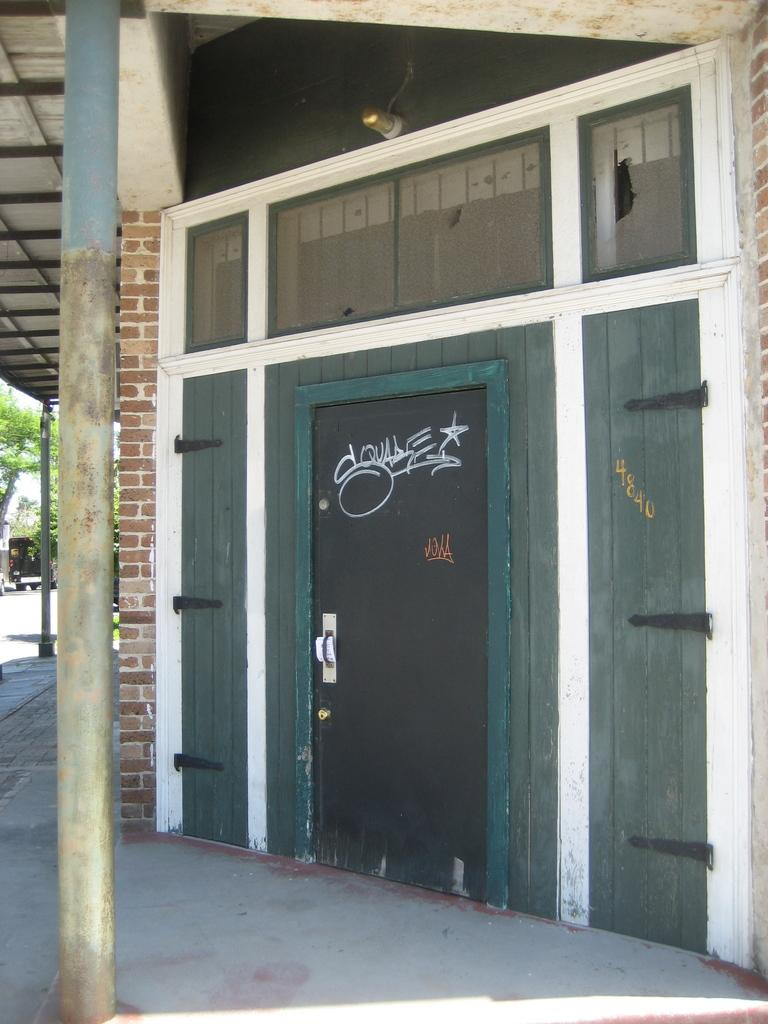What is the main object in the image? There is a pole in the image. What else can be seen in the image besides the pole? There is a door in the image. What is the color of the door? The door is black in color. Is there any text on the door? Yes, there is text written on the door. How many dogs are sitting on the pole in the image? There are no dogs present in the image, and the pole is not a place for dogs to sit. 